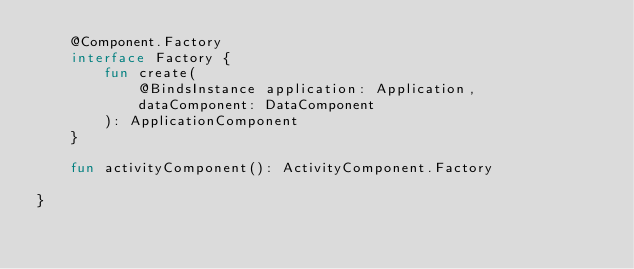<code> <loc_0><loc_0><loc_500><loc_500><_Kotlin_>    @Component.Factory
    interface Factory {
        fun create(
            @BindsInstance application: Application,
            dataComponent: DataComponent
        ): ApplicationComponent
    }

    fun activityComponent(): ActivityComponent.Factory

}
</code> 